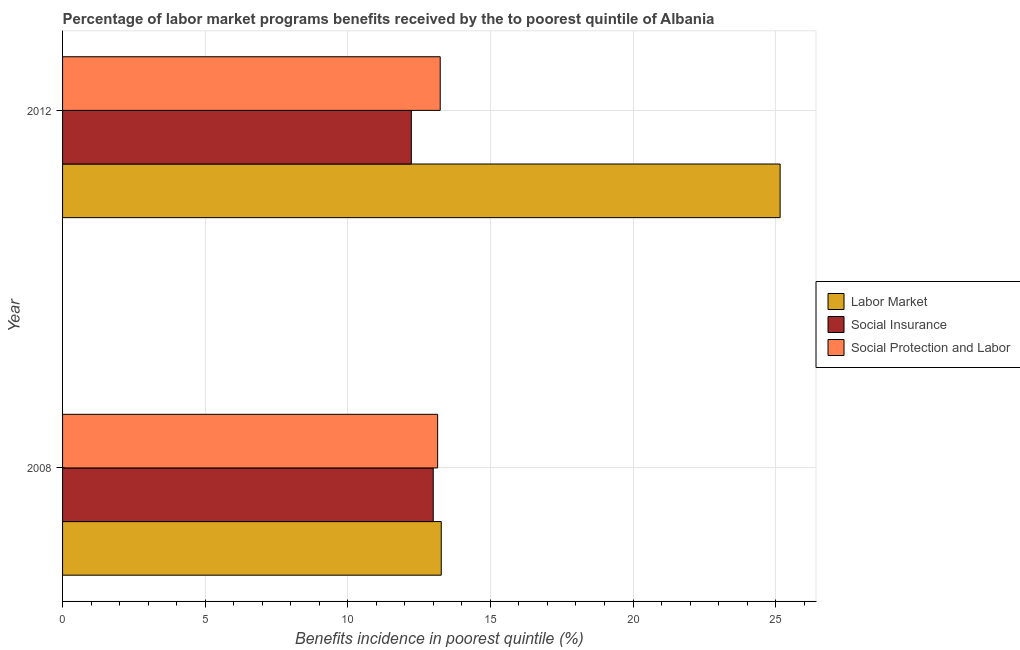How many different coloured bars are there?
Your answer should be very brief. 3. How many groups of bars are there?
Keep it short and to the point. 2. Are the number of bars per tick equal to the number of legend labels?
Offer a terse response. Yes. Are the number of bars on each tick of the Y-axis equal?
Provide a short and direct response. Yes. How many bars are there on the 1st tick from the top?
Provide a succinct answer. 3. How many bars are there on the 1st tick from the bottom?
Ensure brevity in your answer.  3. In how many cases, is the number of bars for a given year not equal to the number of legend labels?
Your answer should be very brief. 0. What is the percentage of benefits received due to social insurance programs in 2012?
Keep it short and to the point. 12.23. Across all years, what is the maximum percentage of benefits received due to labor market programs?
Offer a terse response. 25.16. Across all years, what is the minimum percentage of benefits received due to social insurance programs?
Keep it short and to the point. 12.23. What is the total percentage of benefits received due to labor market programs in the graph?
Ensure brevity in your answer.  38.44. What is the difference between the percentage of benefits received due to social insurance programs in 2008 and that in 2012?
Provide a succinct answer. 0.77. What is the difference between the percentage of benefits received due to labor market programs in 2008 and the percentage of benefits received due to social protection programs in 2012?
Keep it short and to the point. 0.04. What is the average percentage of benefits received due to labor market programs per year?
Your answer should be very brief. 19.22. In the year 2012, what is the difference between the percentage of benefits received due to social insurance programs and percentage of benefits received due to labor market programs?
Provide a short and direct response. -12.93. Is the percentage of benefits received due to labor market programs in 2008 less than that in 2012?
Offer a very short reply. Yes. In how many years, is the percentage of benefits received due to labor market programs greater than the average percentage of benefits received due to labor market programs taken over all years?
Ensure brevity in your answer.  1. What does the 2nd bar from the top in 2012 represents?
Offer a terse response. Social Insurance. What does the 2nd bar from the bottom in 2012 represents?
Provide a succinct answer. Social Insurance. Is it the case that in every year, the sum of the percentage of benefits received due to labor market programs and percentage of benefits received due to social insurance programs is greater than the percentage of benefits received due to social protection programs?
Your response must be concise. Yes. Are the values on the major ticks of X-axis written in scientific E-notation?
Offer a terse response. No. Does the graph contain any zero values?
Provide a short and direct response. No. Does the graph contain grids?
Keep it short and to the point. Yes. Where does the legend appear in the graph?
Your answer should be very brief. Center right. How many legend labels are there?
Make the answer very short. 3. What is the title of the graph?
Give a very brief answer. Percentage of labor market programs benefits received by the to poorest quintile of Albania. Does "Social Insurance" appear as one of the legend labels in the graph?
Your answer should be very brief. Yes. What is the label or title of the X-axis?
Offer a terse response. Benefits incidence in poorest quintile (%). What is the Benefits incidence in poorest quintile (%) of Labor Market in 2008?
Offer a terse response. 13.28. What is the Benefits incidence in poorest quintile (%) of Social Insurance in 2008?
Offer a very short reply. 13. What is the Benefits incidence in poorest quintile (%) of Social Protection and Labor in 2008?
Offer a terse response. 13.15. What is the Benefits incidence in poorest quintile (%) in Labor Market in 2012?
Offer a terse response. 25.16. What is the Benefits incidence in poorest quintile (%) in Social Insurance in 2012?
Your answer should be compact. 12.23. What is the Benefits incidence in poorest quintile (%) in Social Protection and Labor in 2012?
Your response must be concise. 13.24. Across all years, what is the maximum Benefits incidence in poorest quintile (%) in Labor Market?
Offer a terse response. 25.16. Across all years, what is the maximum Benefits incidence in poorest quintile (%) in Social Insurance?
Give a very brief answer. 13. Across all years, what is the maximum Benefits incidence in poorest quintile (%) in Social Protection and Labor?
Provide a short and direct response. 13.24. Across all years, what is the minimum Benefits incidence in poorest quintile (%) of Labor Market?
Your answer should be very brief. 13.28. Across all years, what is the minimum Benefits incidence in poorest quintile (%) of Social Insurance?
Make the answer very short. 12.23. Across all years, what is the minimum Benefits incidence in poorest quintile (%) in Social Protection and Labor?
Your answer should be compact. 13.15. What is the total Benefits incidence in poorest quintile (%) in Labor Market in the graph?
Your response must be concise. 38.44. What is the total Benefits incidence in poorest quintile (%) in Social Insurance in the graph?
Make the answer very short. 25.22. What is the total Benefits incidence in poorest quintile (%) of Social Protection and Labor in the graph?
Your response must be concise. 26.39. What is the difference between the Benefits incidence in poorest quintile (%) of Labor Market in 2008 and that in 2012?
Ensure brevity in your answer.  -11.88. What is the difference between the Benefits incidence in poorest quintile (%) in Social Insurance in 2008 and that in 2012?
Your answer should be very brief. 0.77. What is the difference between the Benefits incidence in poorest quintile (%) in Social Protection and Labor in 2008 and that in 2012?
Give a very brief answer. -0.09. What is the difference between the Benefits incidence in poorest quintile (%) of Labor Market in 2008 and the Benefits incidence in poorest quintile (%) of Social Insurance in 2012?
Give a very brief answer. 1.05. What is the difference between the Benefits incidence in poorest quintile (%) in Labor Market in 2008 and the Benefits incidence in poorest quintile (%) in Social Protection and Labor in 2012?
Ensure brevity in your answer.  0.04. What is the difference between the Benefits incidence in poorest quintile (%) in Social Insurance in 2008 and the Benefits incidence in poorest quintile (%) in Social Protection and Labor in 2012?
Keep it short and to the point. -0.24. What is the average Benefits incidence in poorest quintile (%) in Labor Market per year?
Provide a succinct answer. 19.22. What is the average Benefits incidence in poorest quintile (%) in Social Insurance per year?
Ensure brevity in your answer.  12.61. What is the average Benefits incidence in poorest quintile (%) in Social Protection and Labor per year?
Offer a very short reply. 13.2. In the year 2008, what is the difference between the Benefits incidence in poorest quintile (%) in Labor Market and Benefits incidence in poorest quintile (%) in Social Insurance?
Give a very brief answer. 0.28. In the year 2008, what is the difference between the Benefits incidence in poorest quintile (%) in Labor Market and Benefits incidence in poorest quintile (%) in Social Protection and Labor?
Your answer should be compact. 0.13. In the year 2008, what is the difference between the Benefits incidence in poorest quintile (%) in Social Insurance and Benefits incidence in poorest quintile (%) in Social Protection and Labor?
Keep it short and to the point. -0.15. In the year 2012, what is the difference between the Benefits incidence in poorest quintile (%) of Labor Market and Benefits incidence in poorest quintile (%) of Social Insurance?
Your response must be concise. 12.93. In the year 2012, what is the difference between the Benefits incidence in poorest quintile (%) of Labor Market and Benefits incidence in poorest quintile (%) of Social Protection and Labor?
Your answer should be compact. 11.92. In the year 2012, what is the difference between the Benefits incidence in poorest quintile (%) in Social Insurance and Benefits incidence in poorest quintile (%) in Social Protection and Labor?
Offer a very short reply. -1.01. What is the ratio of the Benefits incidence in poorest quintile (%) of Labor Market in 2008 to that in 2012?
Provide a short and direct response. 0.53. What is the ratio of the Benefits incidence in poorest quintile (%) in Social Insurance in 2008 to that in 2012?
Offer a terse response. 1.06. What is the difference between the highest and the second highest Benefits incidence in poorest quintile (%) in Labor Market?
Your response must be concise. 11.88. What is the difference between the highest and the second highest Benefits incidence in poorest quintile (%) of Social Insurance?
Your response must be concise. 0.77. What is the difference between the highest and the second highest Benefits incidence in poorest quintile (%) of Social Protection and Labor?
Make the answer very short. 0.09. What is the difference between the highest and the lowest Benefits incidence in poorest quintile (%) in Labor Market?
Offer a very short reply. 11.88. What is the difference between the highest and the lowest Benefits incidence in poorest quintile (%) in Social Insurance?
Provide a short and direct response. 0.77. What is the difference between the highest and the lowest Benefits incidence in poorest quintile (%) of Social Protection and Labor?
Offer a terse response. 0.09. 